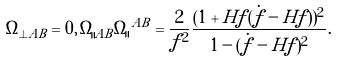Convert formula to latex. <formula><loc_0><loc_0><loc_500><loc_500>\Omega _ { \perp A B } = 0 , \, \Omega _ { \| A B } \Omega _ { \| } \, ^ { A B } = \frac { 2 } { f ^ { 2 } } \frac { ( 1 + H f ( \dot { f } - H f ) ) ^ { 2 } } { 1 - ( \dot { f } - H f ) ^ { 2 } } .</formula> 